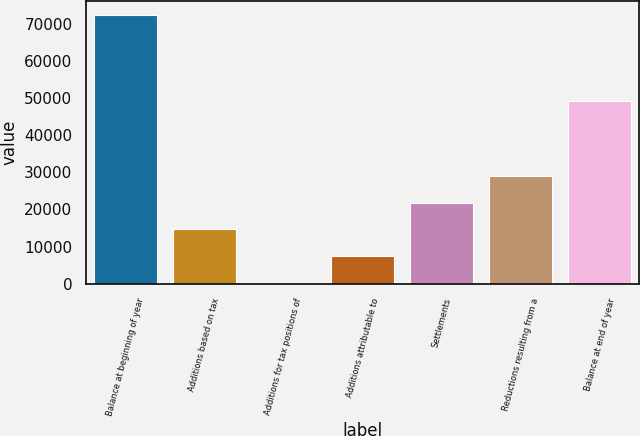Convert chart to OTSL. <chart><loc_0><loc_0><loc_500><loc_500><bar_chart><fcel>Balance at beginning of year<fcel>Additions based on tax<fcel>Additions for tax positions of<fcel>Additions attributable to<fcel>Settlements<fcel>Reductions resulting from a<fcel>Balance at end of year<nl><fcel>72547<fcel>14626.2<fcel>146<fcel>7386.1<fcel>21866.3<fcel>29106.4<fcel>49338<nl></chart> 